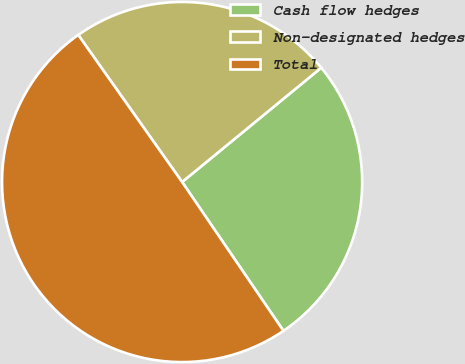Convert chart to OTSL. <chart><loc_0><loc_0><loc_500><loc_500><pie_chart><fcel>Cash flow hedges<fcel>Non-designated hedges<fcel>Total<nl><fcel>26.43%<fcel>23.84%<fcel>49.73%<nl></chart> 